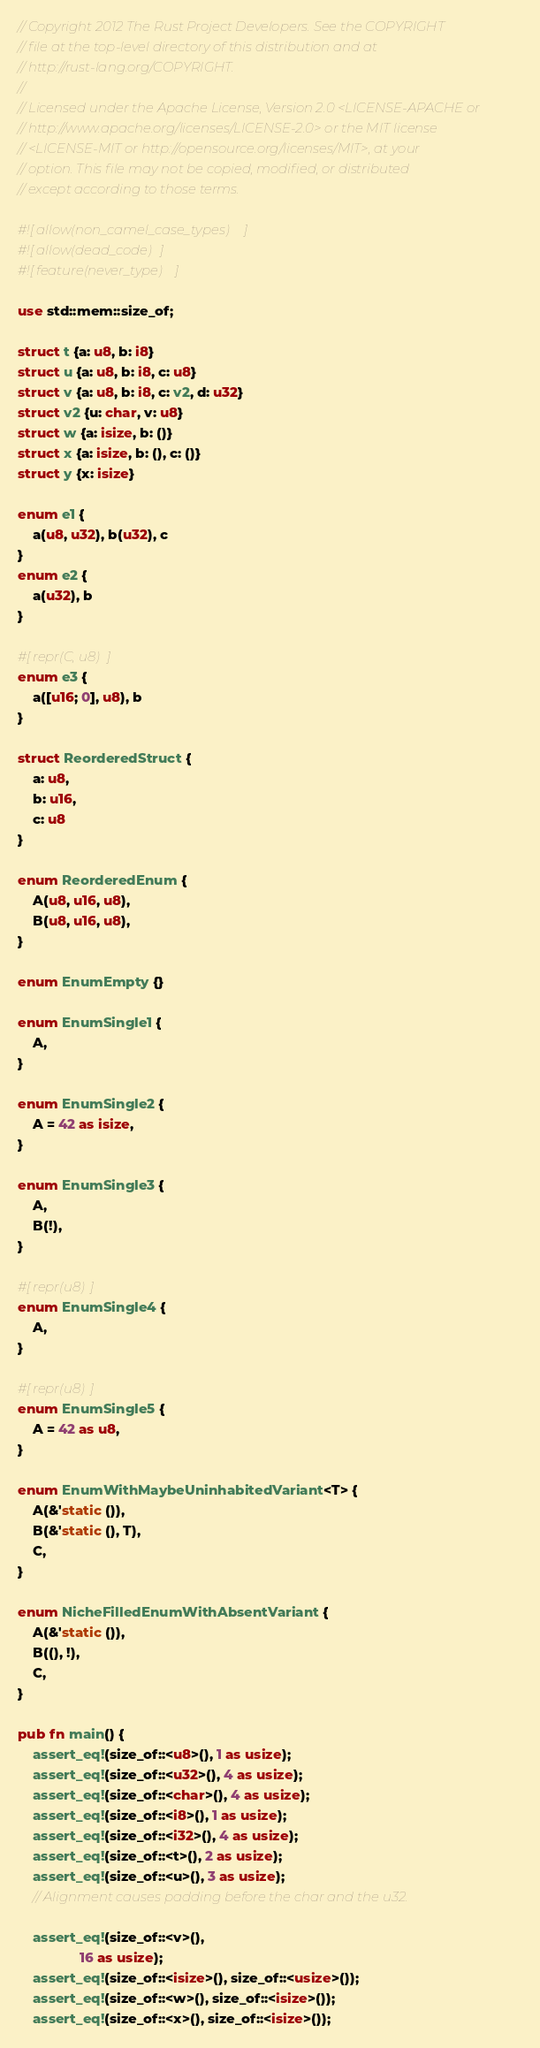<code> <loc_0><loc_0><loc_500><loc_500><_Rust_>// Copyright 2012 The Rust Project Developers. See the COPYRIGHT
// file at the top-level directory of this distribution and at
// http://rust-lang.org/COPYRIGHT.
//
// Licensed under the Apache License, Version 2.0 <LICENSE-APACHE or
// http://www.apache.org/licenses/LICENSE-2.0> or the MIT license
// <LICENSE-MIT or http://opensource.org/licenses/MIT>, at your
// option. This file may not be copied, modified, or distributed
// except according to those terms.

#![allow(non_camel_case_types)]
#![allow(dead_code)]
#![feature(never_type)]

use std::mem::size_of;

struct t {a: u8, b: i8}
struct u {a: u8, b: i8, c: u8}
struct v {a: u8, b: i8, c: v2, d: u32}
struct v2 {u: char, v: u8}
struct w {a: isize, b: ()}
struct x {a: isize, b: (), c: ()}
struct y {x: isize}

enum e1 {
    a(u8, u32), b(u32), c
}
enum e2 {
    a(u32), b
}

#[repr(C, u8)]
enum e3 {
    a([u16; 0], u8), b
}

struct ReorderedStruct {
    a: u8,
    b: u16,
    c: u8
}

enum ReorderedEnum {
    A(u8, u16, u8),
    B(u8, u16, u8),
}

enum EnumEmpty {}

enum EnumSingle1 {
    A,
}

enum EnumSingle2 {
    A = 42 as isize,
}

enum EnumSingle3 {
    A,
    B(!),
}

#[repr(u8)]
enum EnumSingle4 {
    A,
}

#[repr(u8)]
enum EnumSingle5 {
    A = 42 as u8,
}

enum EnumWithMaybeUninhabitedVariant<T> {
    A(&'static ()),
    B(&'static (), T),
    C,
}

enum NicheFilledEnumWithAbsentVariant {
    A(&'static ()),
    B((), !),
    C,
}

pub fn main() {
    assert_eq!(size_of::<u8>(), 1 as usize);
    assert_eq!(size_of::<u32>(), 4 as usize);
    assert_eq!(size_of::<char>(), 4 as usize);
    assert_eq!(size_of::<i8>(), 1 as usize);
    assert_eq!(size_of::<i32>(), 4 as usize);
    assert_eq!(size_of::<t>(), 2 as usize);
    assert_eq!(size_of::<u>(), 3 as usize);
    // Alignment causes padding before the char and the u32.

    assert_eq!(size_of::<v>(),
                16 as usize);
    assert_eq!(size_of::<isize>(), size_of::<usize>());
    assert_eq!(size_of::<w>(), size_of::<isize>());
    assert_eq!(size_of::<x>(), size_of::<isize>());</code> 